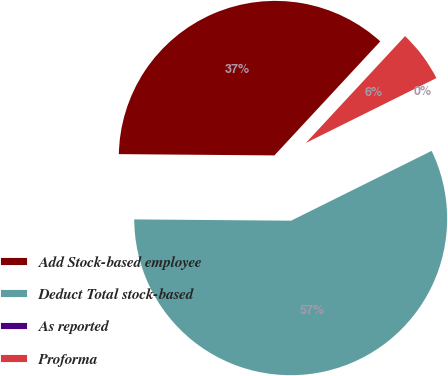Convert chart to OTSL. <chart><loc_0><loc_0><loc_500><loc_500><pie_chart><fcel>Add Stock-based employee<fcel>Deduct Total stock-based<fcel>As reported<fcel>Proforma<nl><fcel>36.78%<fcel>57.47%<fcel>0.0%<fcel>5.75%<nl></chart> 